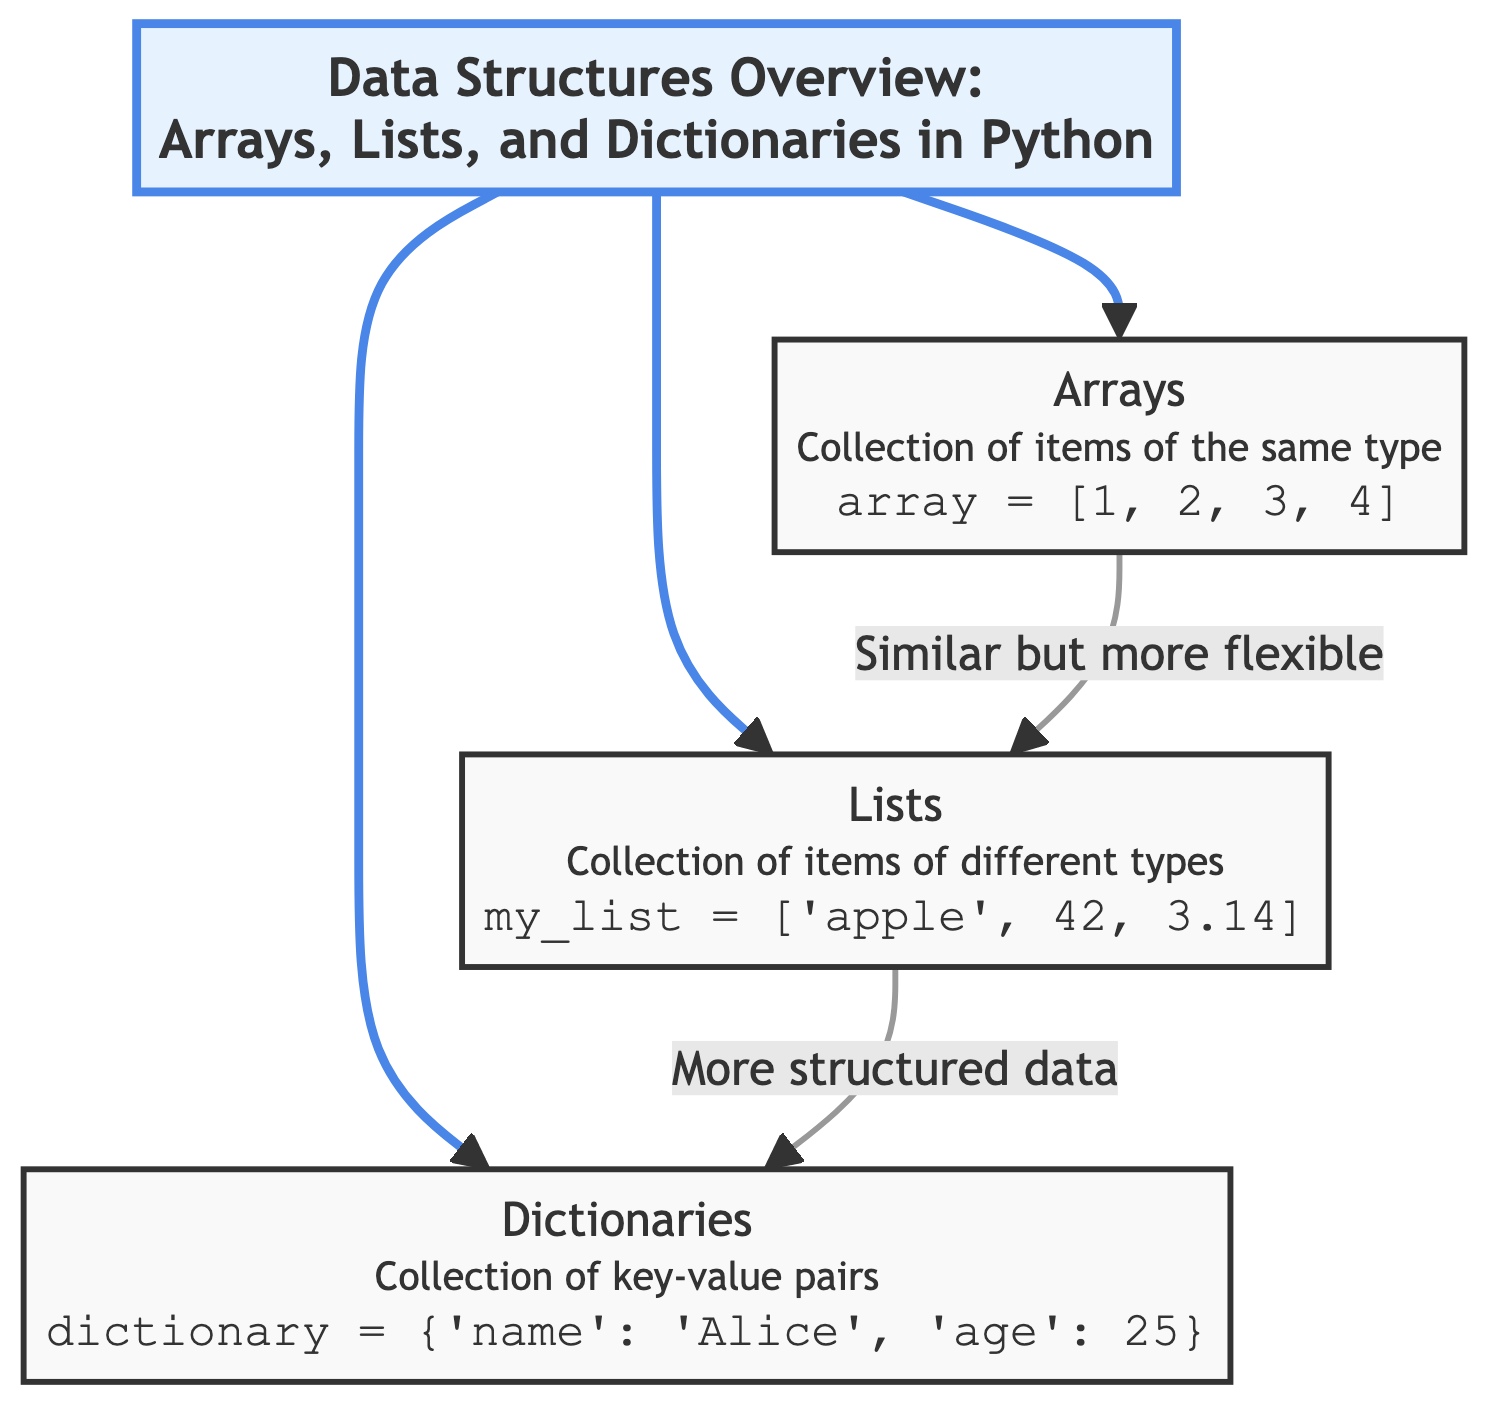What is the title of the diagram? The title of the diagram is explicitly displayed at the top and reads "Data Structures Overview: Arrays, Lists, and Dictionaries in Python".
Answer: Data Structures Overview: Arrays, Lists, and Dictionaries in Python How many main data structure types are shown in the diagram? The diagram presents three main types of data structures: Arrays, Lists, and Dictionaries. This can be counted in the different nodes branching from the title.
Answer: 3 What type of collection do Arrays represent? According to the diagram's description under the Arrays node, they represent a collection of items of the same type.
Answer: Collection of items of the same type What code snippet defines a List in Python? The diagram clearly shows the code snippet for defining a List, which is `my_list = ['apple', 42, 3.14]`. This can be found in the Lists section.
Answer: my_list = ['apple', 42, 3.14] What do Lists have in comparison to Arrays according to the diagram? The diagram states that Lists are more flexible than Arrays. This comparison is indicated by the linking arrow between the two structures.
Answer: More flexible What do Dictionaries consist of? The description under the Dictionaries node states that they consist of key-value pairs. This is a key concept explained for this data structure.
Answer: Collection of key-value pairs How are Lists described in relation to Dictionaries? The diagram indicates that Lists provide more structured data compared to Dictionaries. This is evident in the notation connecting the two nodes.
Answer: More structured data Which data structure can hold items of different types? The Lists node specifically mentions that it can hold items of different types, such as strings and numbers.
Answer: Lists What do the connections between the three data structures represent? The connections illustrate the relationships and comparative qualities between Arrays, Lists, and Dictionaries. They show how one data structure can relate or differ from another in functionality.
Answer: Relationships and comparative qualities 